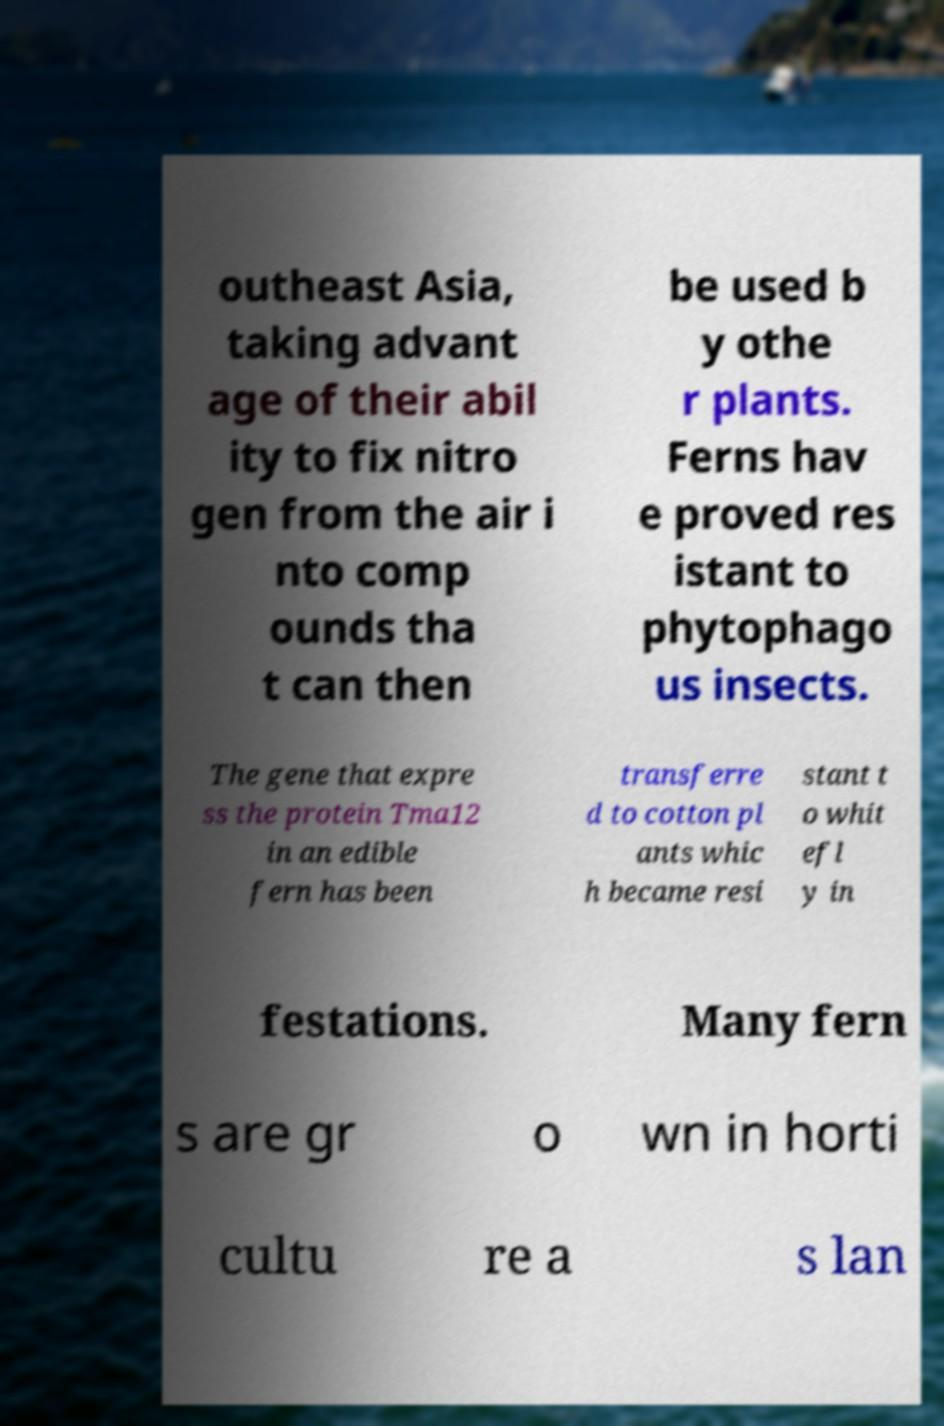Could you assist in decoding the text presented in this image and type it out clearly? outheast Asia, taking advant age of their abil ity to fix nitro gen from the air i nto comp ounds tha t can then be used b y othe r plants. Ferns hav e proved res istant to phytophago us insects. The gene that expre ss the protein Tma12 in an edible fern has been transferre d to cotton pl ants whic h became resi stant t o whit efl y in festations. Many fern s are gr o wn in horti cultu re a s lan 